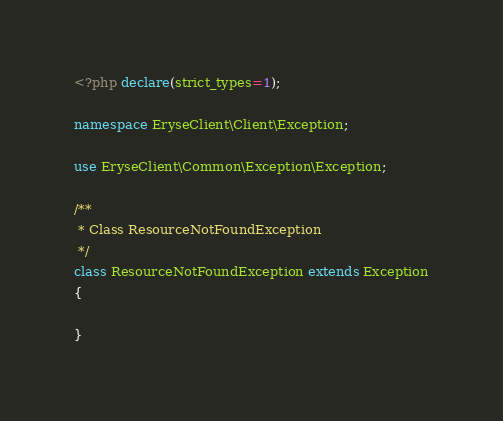<code> <loc_0><loc_0><loc_500><loc_500><_PHP_><?php declare(strict_types=1);

namespace EryseClient\Client\Exception;

use EryseClient\Common\Exception\Exception;

/**
 * Class ResourceNotFoundException
 */
class ResourceNotFoundException extends Exception
{

}
</code> 